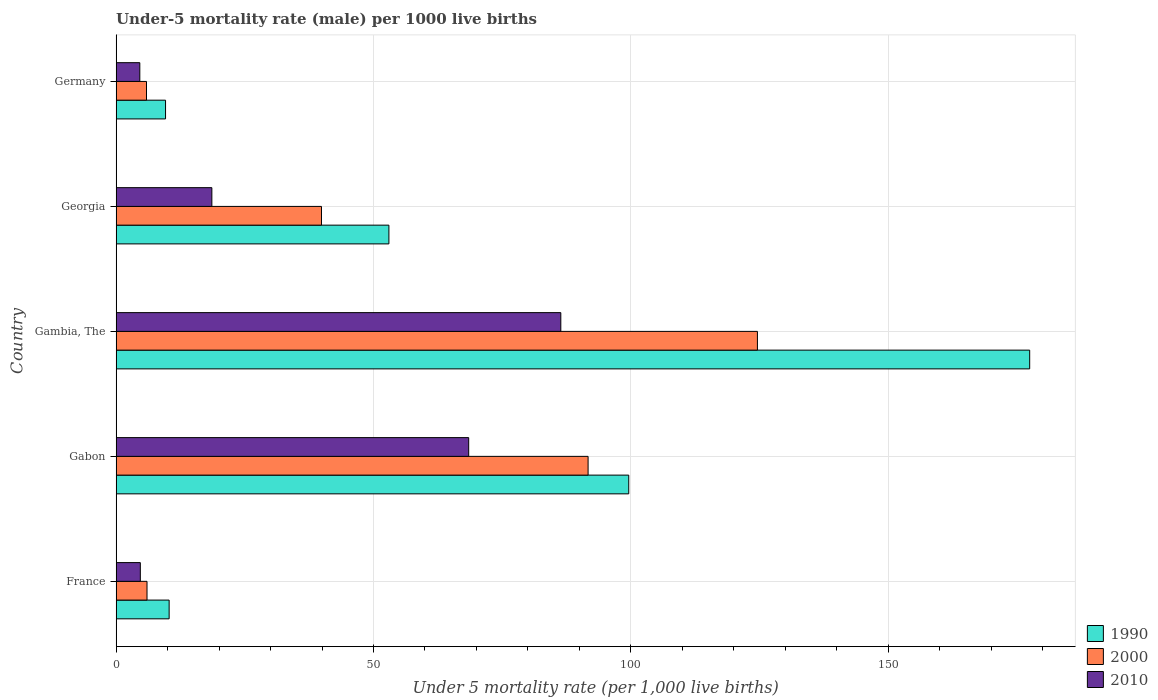How many different coloured bars are there?
Provide a succinct answer. 3. How many groups of bars are there?
Your answer should be very brief. 5. Are the number of bars per tick equal to the number of legend labels?
Provide a succinct answer. Yes. How many bars are there on the 3rd tick from the top?
Give a very brief answer. 3. How many bars are there on the 4th tick from the bottom?
Keep it short and to the point. 3. What is the label of the 2nd group of bars from the top?
Provide a succinct answer. Georgia. Across all countries, what is the maximum under-five mortality rate in 2010?
Provide a short and direct response. 86.4. In which country was the under-five mortality rate in 2000 maximum?
Your response must be concise. Gambia, The. In which country was the under-five mortality rate in 2010 minimum?
Your response must be concise. Germany. What is the total under-five mortality rate in 2000 in the graph?
Your response must be concise. 268.1. What is the difference between the under-five mortality rate in 1990 in France and that in Germany?
Your response must be concise. 0.7. What is the difference between the under-five mortality rate in 2010 in Gambia, The and the under-five mortality rate in 2000 in Georgia?
Your response must be concise. 46.5. What is the average under-five mortality rate in 2000 per country?
Your answer should be very brief. 53.62. What is the difference between the under-five mortality rate in 2010 and under-five mortality rate in 2000 in Germany?
Give a very brief answer. -1.3. What is the ratio of the under-five mortality rate in 2010 in Gabon to that in Gambia, The?
Your answer should be compact. 0.79. Is the under-five mortality rate in 1990 in France less than that in Germany?
Offer a terse response. No. What is the difference between the highest and the second highest under-five mortality rate in 1990?
Offer a very short reply. 77.9. What is the difference between the highest and the lowest under-five mortality rate in 1990?
Offer a terse response. 167.9. In how many countries, is the under-five mortality rate in 1990 greater than the average under-five mortality rate in 1990 taken over all countries?
Your response must be concise. 2. Is the sum of the under-five mortality rate in 1990 in France and Georgia greater than the maximum under-five mortality rate in 2000 across all countries?
Your answer should be very brief. No. How many bars are there?
Offer a terse response. 15. Are all the bars in the graph horizontal?
Keep it short and to the point. Yes. What is the difference between two consecutive major ticks on the X-axis?
Your response must be concise. 50. Does the graph contain any zero values?
Offer a very short reply. No. How many legend labels are there?
Give a very brief answer. 3. What is the title of the graph?
Provide a short and direct response. Under-5 mortality rate (male) per 1000 live births. Does "2009" appear as one of the legend labels in the graph?
Ensure brevity in your answer.  No. What is the label or title of the X-axis?
Offer a very short reply. Under 5 mortality rate (per 1,0 live births). What is the label or title of the Y-axis?
Offer a very short reply. Country. What is the Under 5 mortality rate (per 1,000 live births) of 1990 in France?
Offer a very short reply. 10.3. What is the Under 5 mortality rate (per 1,000 live births) of 1990 in Gabon?
Provide a succinct answer. 99.6. What is the Under 5 mortality rate (per 1,000 live births) in 2000 in Gabon?
Make the answer very short. 91.7. What is the Under 5 mortality rate (per 1,000 live births) of 2010 in Gabon?
Your answer should be very brief. 68.5. What is the Under 5 mortality rate (per 1,000 live births) in 1990 in Gambia, The?
Your answer should be compact. 177.5. What is the Under 5 mortality rate (per 1,000 live births) in 2000 in Gambia, The?
Offer a terse response. 124.6. What is the Under 5 mortality rate (per 1,000 live births) in 2010 in Gambia, The?
Your answer should be compact. 86.4. What is the Under 5 mortality rate (per 1,000 live births) in 1990 in Georgia?
Your answer should be compact. 53. What is the Under 5 mortality rate (per 1,000 live births) in 2000 in Georgia?
Your response must be concise. 39.9. What is the Under 5 mortality rate (per 1,000 live births) of 2000 in Germany?
Provide a succinct answer. 5.9. Across all countries, what is the maximum Under 5 mortality rate (per 1,000 live births) of 1990?
Your response must be concise. 177.5. Across all countries, what is the maximum Under 5 mortality rate (per 1,000 live births) in 2000?
Your answer should be compact. 124.6. Across all countries, what is the maximum Under 5 mortality rate (per 1,000 live births) in 2010?
Give a very brief answer. 86.4. Across all countries, what is the minimum Under 5 mortality rate (per 1,000 live births) in 1990?
Your answer should be very brief. 9.6. What is the total Under 5 mortality rate (per 1,000 live births) in 1990 in the graph?
Keep it short and to the point. 350. What is the total Under 5 mortality rate (per 1,000 live births) in 2000 in the graph?
Ensure brevity in your answer.  268.1. What is the total Under 5 mortality rate (per 1,000 live births) in 2010 in the graph?
Offer a very short reply. 182.8. What is the difference between the Under 5 mortality rate (per 1,000 live births) in 1990 in France and that in Gabon?
Provide a succinct answer. -89.3. What is the difference between the Under 5 mortality rate (per 1,000 live births) in 2000 in France and that in Gabon?
Your answer should be very brief. -85.7. What is the difference between the Under 5 mortality rate (per 1,000 live births) in 2010 in France and that in Gabon?
Provide a succinct answer. -63.8. What is the difference between the Under 5 mortality rate (per 1,000 live births) in 1990 in France and that in Gambia, The?
Offer a terse response. -167.2. What is the difference between the Under 5 mortality rate (per 1,000 live births) in 2000 in France and that in Gambia, The?
Make the answer very short. -118.6. What is the difference between the Under 5 mortality rate (per 1,000 live births) in 2010 in France and that in Gambia, The?
Your answer should be compact. -81.7. What is the difference between the Under 5 mortality rate (per 1,000 live births) in 1990 in France and that in Georgia?
Keep it short and to the point. -42.7. What is the difference between the Under 5 mortality rate (per 1,000 live births) of 2000 in France and that in Georgia?
Your answer should be very brief. -33.9. What is the difference between the Under 5 mortality rate (per 1,000 live births) in 1990 in France and that in Germany?
Provide a short and direct response. 0.7. What is the difference between the Under 5 mortality rate (per 1,000 live births) in 1990 in Gabon and that in Gambia, The?
Offer a terse response. -77.9. What is the difference between the Under 5 mortality rate (per 1,000 live births) in 2000 in Gabon and that in Gambia, The?
Offer a terse response. -32.9. What is the difference between the Under 5 mortality rate (per 1,000 live births) of 2010 in Gabon and that in Gambia, The?
Ensure brevity in your answer.  -17.9. What is the difference between the Under 5 mortality rate (per 1,000 live births) in 1990 in Gabon and that in Georgia?
Keep it short and to the point. 46.6. What is the difference between the Under 5 mortality rate (per 1,000 live births) of 2000 in Gabon and that in Georgia?
Your answer should be compact. 51.8. What is the difference between the Under 5 mortality rate (per 1,000 live births) of 2010 in Gabon and that in Georgia?
Keep it short and to the point. 49.9. What is the difference between the Under 5 mortality rate (per 1,000 live births) of 2000 in Gabon and that in Germany?
Make the answer very short. 85.8. What is the difference between the Under 5 mortality rate (per 1,000 live births) of 2010 in Gabon and that in Germany?
Keep it short and to the point. 63.9. What is the difference between the Under 5 mortality rate (per 1,000 live births) in 1990 in Gambia, The and that in Georgia?
Keep it short and to the point. 124.5. What is the difference between the Under 5 mortality rate (per 1,000 live births) of 2000 in Gambia, The and that in Georgia?
Offer a terse response. 84.7. What is the difference between the Under 5 mortality rate (per 1,000 live births) of 2010 in Gambia, The and that in Georgia?
Your answer should be compact. 67.8. What is the difference between the Under 5 mortality rate (per 1,000 live births) in 1990 in Gambia, The and that in Germany?
Your answer should be compact. 167.9. What is the difference between the Under 5 mortality rate (per 1,000 live births) in 2000 in Gambia, The and that in Germany?
Give a very brief answer. 118.7. What is the difference between the Under 5 mortality rate (per 1,000 live births) of 2010 in Gambia, The and that in Germany?
Offer a very short reply. 81.8. What is the difference between the Under 5 mortality rate (per 1,000 live births) of 1990 in Georgia and that in Germany?
Your answer should be compact. 43.4. What is the difference between the Under 5 mortality rate (per 1,000 live births) in 2010 in Georgia and that in Germany?
Give a very brief answer. 14. What is the difference between the Under 5 mortality rate (per 1,000 live births) of 1990 in France and the Under 5 mortality rate (per 1,000 live births) of 2000 in Gabon?
Keep it short and to the point. -81.4. What is the difference between the Under 5 mortality rate (per 1,000 live births) in 1990 in France and the Under 5 mortality rate (per 1,000 live births) in 2010 in Gabon?
Make the answer very short. -58.2. What is the difference between the Under 5 mortality rate (per 1,000 live births) in 2000 in France and the Under 5 mortality rate (per 1,000 live births) in 2010 in Gabon?
Your response must be concise. -62.5. What is the difference between the Under 5 mortality rate (per 1,000 live births) in 1990 in France and the Under 5 mortality rate (per 1,000 live births) in 2000 in Gambia, The?
Your response must be concise. -114.3. What is the difference between the Under 5 mortality rate (per 1,000 live births) in 1990 in France and the Under 5 mortality rate (per 1,000 live births) in 2010 in Gambia, The?
Keep it short and to the point. -76.1. What is the difference between the Under 5 mortality rate (per 1,000 live births) in 2000 in France and the Under 5 mortality rate (per 1,000 live births) in 2010 in Gambia, The?
Offer a terse response. -80.4. What is the difference between the Under 5 mortality rate (per 1,000 live births) of 1990 in France and the Under 5 mortality rate (per 1,000 live births) of 2000 in Georgia?
Provide a short and direct response. -29.6. What is the difference between the Under 5 mortality rate (per 1,000 live births) of 2000 in France and the Under 5 mortality rate (per 1,000 live births) of 2010 in Georgia?
Provide a short and direct response. -12.6. What is the difference between the Under 5 mortality rate (per 1,000 live births) of 2000 in France and the Under 5 mortality rate (per 1,000 live births) of 2010 in Germany?
Your answer should be compact. 1.4. What is the difference between the Under 5 mortality rate (per 1,000 live births) in 1990 in Gabon and the Under 5 mortality rate (per 1,000 live births) in 2000 in Georgia?
Keep it short and to the point. 59.7. What is the difference between the Under 5 mortality rate (per 1,000 live births) in 2000 in Gabon and the Under 5 mortality rate (per 1,000 live births) in 2010 in Georgia?
Offer a terse response. 73.1. What is the difference between the Under 5 mortality rate (per 1,000 live births) in 1990 in Gabon and the Under 5 mortality rate (per 1,000 live births) in 2000 in Germany?
Make the answer very short. 93.7. What is the difference between the Under 5 mortality rate (per 1,000 live births) in 1990 in Gabon and the Under 5 mortality rate (per 1,000 live births) in 2010 in Germany?
Make the answer very short. 95. What is the difference between the Under 5 mortality rate (per 1,000 live births) of 2000 in Gabon and the Under 5 mortality rate (per 1,000 live births) of 2010 in Germany?
Provide a succinct answer. 87.1. What is the difference between the Under 5 mortality rate (per 1,000 live births) of 1990 in Gambia, The and the Under 5 mortality rate (per 1,000 live births) of 2000 in Georgia?
Your answer should be very brief. 137.6. What is the difference between the Under 5 mortality rate (per 1,000 live births) of 1990 in Gambia, The and the Under 5 mortality rate (per 1,000 live births) of 2010 in Georgia?
Offer a terse response. 158.9. What is the difference between the Under 5 mortality rate (per 1,000 live births) in 2000 in Gambia, The and the Under 5 mortality rate (per 1,000 live births) in 2010 in Georgia?
Provide a short and direct response. 106. What is the difference between the Under 5 mortality rate (per 1,000 live births) of 1990 in Gambia, The and the Under 5 mortality rate (per 1,000 live births) of 2000 in Germany?
Offer a very short reply. 171.6. What is the difference between the Under 5 mortality rate (per 1,000 live births) of 1990 in Gambia, The and the Under 5 mortality rate (per 1,000 live births) of 2010 in Germany?
Offer a very short reply. 172.9. What is the difference between the Under 5 mortality rate (per 1,000 live births) of 2000 in Gambia, The and the Under 5 mortality rate (per 1,000 live births) of 2010 in Germany?
Your answer should be compact. 120. What is the difference between the Under 5 mortality rate (per 1,000 live births) of 1990 in Georgia and the Under 5 mortality rate (per 1,000 live births) of 2000 in Germany?
Provide a succinct answer. 47.1. What is the difference between the Under 5 mortality rate (per 1,000 live births) in 1990 in Georgia and the Under 5 mortality rate (per 1,000 live births) in 2010 in Germany?
Provide a succinct answer. 48.4. What is the difference between the Under 5 mortality rate (per 1,000 live births) in 2000 in Georgia and the Under 5 mortality rate (per 1,000 live births) in 2010 in Germany?
Keep it short and to the point. 35.3. What is the average Under 5 mortality rate (per 1,000 live births) of 2000 per country?
Offer a terse response. 53.62. What is the average Under 5 mortality rate (per 1,000 live births) of 2010 per country?
Provide a short and direct response. 36.56. What is the difference between the Under 5 mortality rate (per 1,000 live births) in 1990 and Under 5 mortality rate (per 1,000 live births) in 2000 in France?
Make the answer very short. 4.3. What is the difference between the Under 5 mortality rate (per 1,000 live births) in 2000 and Under 5 mortality rate (per 1,000 live births) in 2010 in France?
Provide a short and direct response. 1.3. What is the difference between the Under 5 mortality rate (per 1,000 live births) in 1990 and Under 5 mortality rate (per 1,000 live births) in 2000 in Gabon?
Offer a terse response. 7.9. What is the difference between the Under 5 mortality rate (per 1,000 live births) of 1990 and Under 5 mortality rate (per 1,000 live births) of 2010 in Gabon?
Provide a succinct answer. 31.1. What is the difference between the Under 5 mortality rate (per 1,000 live births) of 2000 and Under 5 mortality rate (per 1,000 live births) of 2010 in Gabon?
Provide a succinct answer. 23.2. What is the difference between the Under 5 mortality rate (per 1,000 live births) of 1990 and Under 5 mortality rate (per 1,000 live births) of 2000 in Gambia, The?
Offer a terse response. 52.9. What is the difference between the Under 5 mortality rate (per 1,000 live births) of 1990 and Under 5 mortality rate (per 1,000 live births) of 2010 in Gambia, The?
Your response must be concise. 91.1. What is the difference between the Under 5 mortality rate (per 1,000 live births) in 2000 and Under 5 mortality rate (per 1,000 live births) in 2010 in Gambia, The?
Provide a succinct answer. 38.2. What is the difference between the Under 5 mortality rate (per 1,000 live births) of 1990 and Under 5 mortality rate (per 1,000 live births) of 2010 in Georgia?
Your answer should be very brief. 34.4. What is the difference between the Under 5 mortality rate (per 1,000 live births) of 2000 and Under 5 mortality rate (per 1,000 live births) of 2010 in Georgia?
Offer a terse response. 21.3. What is the difference between the Under 5 mortality rate (per 1,000 live births) of 1990 and Under 5 mortality rate (per 1,000 live births) of 2010 in Germany?
Provide a succinct answer. 5. What is the ratio of the Under 5 mortality rate (per 1,000 live births) of 1990 in France to that in Gabon?
Your answer should be very brief. 0.1. What is the ratio of the Under 5 mortality rate (per 1,000 live births) of 2000 in France to that in Gabon?
Give a very brief answer. 0.07. What is the ratio of the Under 5 mortality rate (per 1,000 live births) of 2010 in France to that in Gabon?
Your answer should be very brief. 0.07. What is the ratio of the Under 5 mortality rate (per 1,000 live births) of 1990 in France to that in Gambia, The?
Give a very brief answer. 0.06. What is the ratio of the Under 5 mortality rate (per 1,000 live births) in 2000 in France to that in Gambia, The?
Give a very brief answer. 0.05. What is the ratio of the Under 5 mortality rate (per 1,000 live births) of 2010 in France to that in Gambia, The?
Offer a very short reply. 0.05. What is the ratio of the Under 5 mortality rate (per 1,000 live births) in 1990 in France to that in Georgia?
Your answer should be very brief. 0.19. What is the ratio of the Under 5 mortality rate (per 1,000 live births) of 2000 in France to that in Georgia?
Give a very brief answer. 0.15. What is the ratio of the Under 5 mortality rate (per 1,000 live births) of 2010 in France to that in Georgia?
Your answer should be compact. 0.25. What is the ratio of the Under 5 mortality rate (per 1,000 live births) in 1990 in France to that in Germany?
Provide a short and direct response. 1.07. What is the ratio of the Under 5 mortality rate (per 1,000 live births) of 2000 in France to that in Germany?
Make the answer very short. 1.02. What is the ratio of the Under 5 mortality rate (per 1,000 live births) in 2010 in France to that in Germany?
Make the answer very short. 1.02. What is the ratio of the Under 5 mortality rate (per 1,000 live births) in 1990 in Gabon to that in Gambia, The?
Provide a short and direct response. 0.56. What is the ratio of the Under 5 mortality rate (per 1,000 live births) in 2000 in Gabon to that in Gambia, The?
Your response must be concise. 0.74. What is the ratio of the Under 5 mortality rate (per 1,000 live births) in 2010 in Gabon to that in Gambia, The?
Make the answer very short. 0.79. What is the ratio of the Under 5 mortality rate (per 1,000 live births) of 1990 in Gabon to that in Georgia?
Keep it short and to the point. 1.88. What is the ratio of the Under 5 mortality rate (per 1,000 live births) in 2000 in Gabon to that in Georgia?
Offer a very short reply. 2.3. What is the ratio of the Under 5 mortality rate (per 1,000 live births) of 2010 in Gabon to that in Georgia?
Your answer should be very brief. 3.68. What is the ratio of the Under 5 mortality rate (per 1,000 live births) in 1990 in Gabon to that in Germany?
Offer a very short reply. 10.38. What is the ratio of the Under 5 mortality rate (per 1,000 live births) in 2000 in Gabon to that in Germany?
Keep it short and to the point. 15.54. What is the ratio of the Under 5 mortality rate (per 1,000 live births) of 2010 in Gabon to that in Germany?
Your response must be concise. 14.89. What is the ratio of the Under 5 mortality rate (per 1,000 live births) in 1990 in Gambia, The to that in Georgia?
Make the answer very short. 3.35. What is the ratio of the Under 5 mortality rate (per 1,000 live births) in 2000 in Gambia, The to that in Georgia?
Make the answer very short. 3.12. What is the ratio of the Under 5 mortality rate (per 1,000 live births) in 2010 in Gambia, The to that in Georgia?
Offer a terse response. 4.65. What is the ratio of the Under 5 mortality rate (per 1,000 live births) in 1990 in Gambia, The to that in Germany?
Offer a terse response. 18.49. What is the ratio of the Under 5 mortality rate (per 1,000 live births) in 2000 in Gambia, The to that in Germany?
Make the answer very short. 21.12. What is the ratio of the Under 5 mortality rate (per 1,000 live births) in 2010 in Gambia, The to that in Germany?
Give a very brief answer. 18.78. What is the ratio of the Under 5 mortality rate (per 1,000 live births) of 1990 in Georgia to that in Germany?
Ensure brevity in your answer.  5.52. What is the ratio of the Under 5 mortality rate (per 1,000 live births) in 2000 in Georgia to that in Germany?
Provide a short and direct response. 6.76. What is the ratio of the Under 5 mortality rate (per 1,000 live births) of 2010 in Georgia to that in Germany?
Keep it short and to the point. 4.04. What is the difference between the highest and the second highest Under 5 mortality rate (per 1,000 live births) of 1990?
Offer a very short reply. 77.9. What is the difference between the highest and the second highest Under 5 mortality rate (per 1,000 live births) of 2000?
Offer a terse response. 32.9. What is the difference between the highest and the second highest Under 5 mortality rate (per 1,000 live births) of 2010?
Your answer should be compact. 17.9. What is the difference between the highest and the lowest Under 5 mortality rate (per 1,000 live births) in 1990?
Your answer should be compact. 167.9. What is the difference between the highest and the lowest Under 5 mortality rate (per 1,000 live births) in 2000?
Your answer should be very brief. 118.7. What is the difference between the highest and the lowest Under 5 mortality rate (per 1,000 live births) in 2010?
Your answer should be compact. 81.8. 